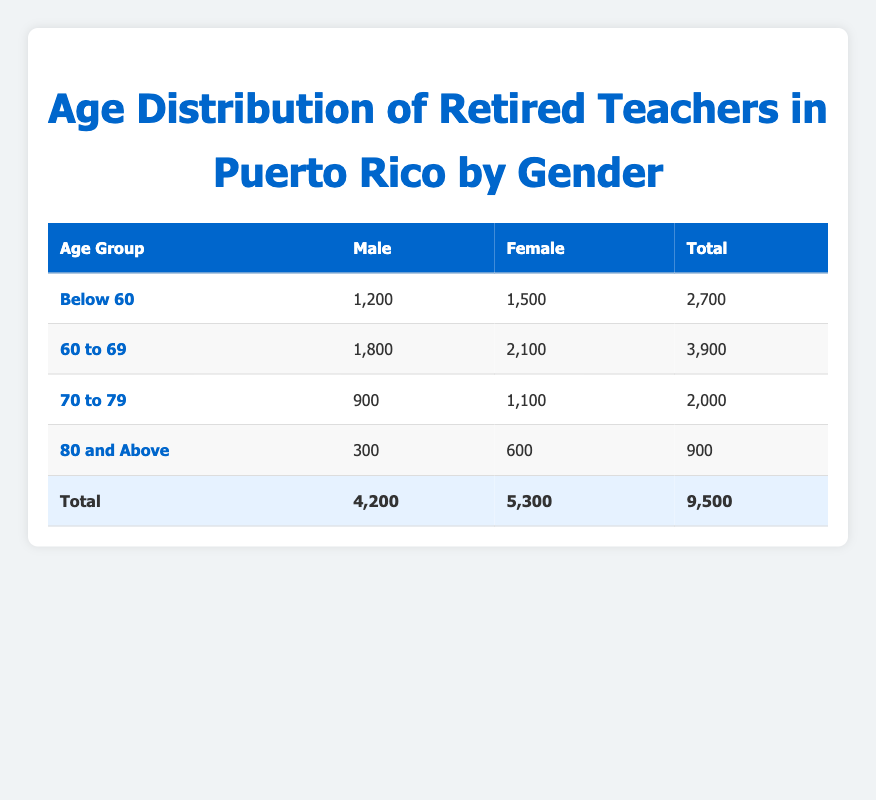What is the total number of retired female teachers in Puerto Rico? To find the total number of retired female teachers, we add the values from all age groups. The numbers are: 1,500 (Below 60) + 2,100 (60 to 69) + 1,100 (70 to 79) + 600 (80 and Above). Summing these gives 1,500 + 2,100 + 1,100 + 600 = 5,300.
Answer: 5,300 How many more male teachers are retired in the age group 60 to 69 than in the 70 to 79 age group? To find the difference, subtract the number of male teachers in the 70 to 79 age group from those in the 60 to 69 age group. The values are: 1,800 (60 to 69) - 900 (70 to 79) = 900.
Answer: 900 Is the total number of retired teachers below 60 years old greater than those aged 80 and above? To answer this, we compare the total retired teachers in both age groups. Below 60 has 2,700 (1,200 males + 1,500 females) and 80 and above has 900 (300 males + 600 females). Since 2,700 > 900, the statement is true.
Answer: Yes What percentage of the total retired teachers are male? First, calculate the total number of retired teachers, which is 9,500. Then, find the number of male retired teachers, which is 4,200. The percentage is calculated by (4,200 / 9,500) * 100. This gives approximately 44.21%.
Answer: 44.21% Which age group has the highest number of retired female teachers? By examining the table, the female numbers in each age group are: 1,500 (Below 60), 2,100 (60 to 69), 1,100 (70 to 79), and 600 (80 and Above). The highest value is 2,100 in the 60 to 69 age group.
Answer: 60 to 69 